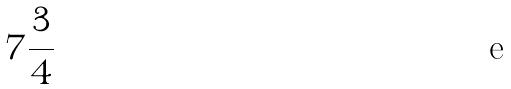<formula> <loc_0><loc_0><loc_500><loc_500>7 \frac { 3 } { 4 }</formula> 